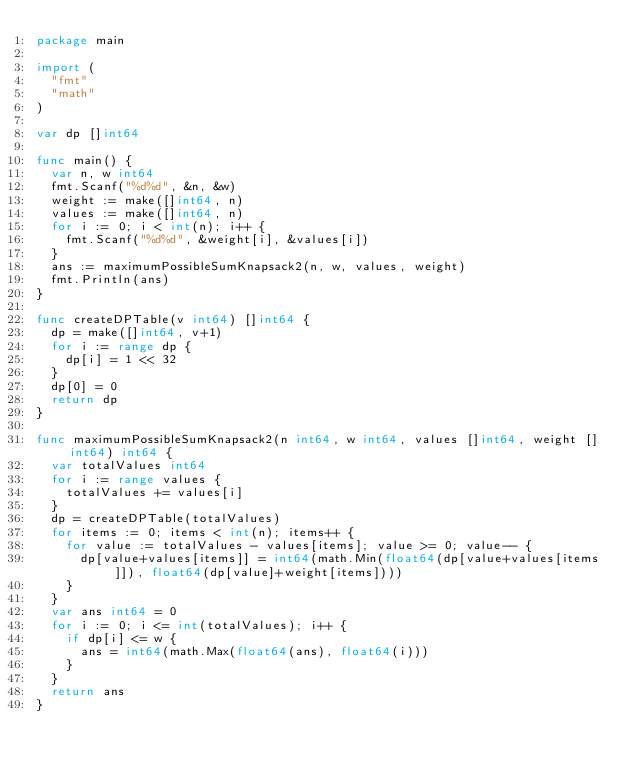<code> <loc_0><loc_0><loc_500><loc_500><_Go_>package main

import (
	"fmt"
	"math"
)

var dp []int64

func main() {
	var n, w int64
	fmt.Scanf("%d%d", &n, &w)
	weight := make([]int64, n)
	values := make([]int64, n)
	for i := 0; i < int(n); i++ {
		fmt.Scanf("%d%d", &weight[i], &values[i])
	}
	ans := maximumPossibleSumKnapsack2(n, w, values, weight)
	fmt.Println(ans)
}

func createDPTable(v int64) []int64 {
	dp = make([]int64, v+1)
	for i := range dp {
		dp[i] = 1 << 32
	}
	dp[0] = 0
	return dp
}

func maximumPossibleSumKnapsack2(n int64, w int64, values []int64, weight []int64) int64 {
	var totalValues int64
	for i := range values {
		totalValues += values[i]
	}
	dp = createDPTable(totalValues)
	for items := 0; items < int(n); items++ {
		for value := totalValues - values[items]; value >= 0; value-- {
			dp[value+values[items]] = int64(math.Min(float64(dp[value+values[items]]), float64(dp[value]+weight[items])))
		}
	}
	var ans int64 = 0
	for i := 0; i <= int(totalValues); i++ {
		if dp[i] <= w {
			ans = int64(math.Max(float64(ans), float64(i)))
		}
	}
	return ans
}
</code> 